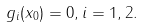<formula> <loc_0><loc_0><loc_500><loc_500>g _ { i } ( x _ { 0 } ) = 0 , i = 1 , 2 .</formula> 